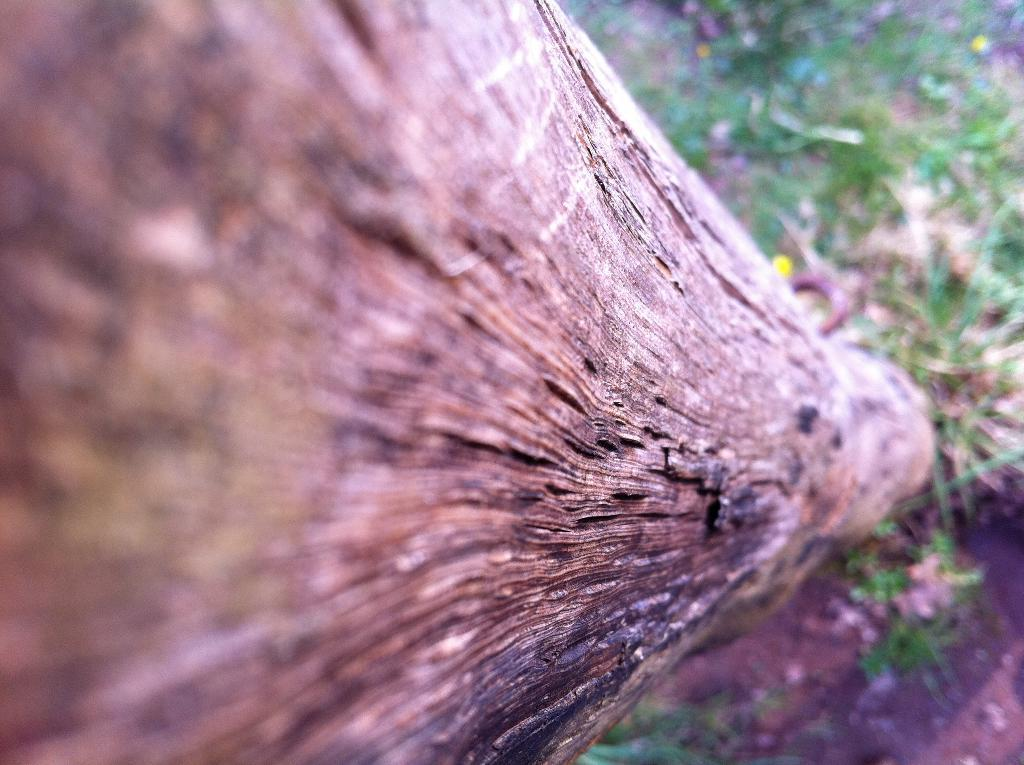What is the main subject of the image? The main subject of the image is the bark of a tree. What type of vegetation can be seen at the bottom of the image? There is green grass at the bottom of the image. How many jellyfish can be seen swimming in the image? There are no jellyfish present in the image; it features the bark of a tree and green grass. What type of motion can be observed in the image? The image does not depict any motion; it is a still image of the bark of a tree and green grass. 